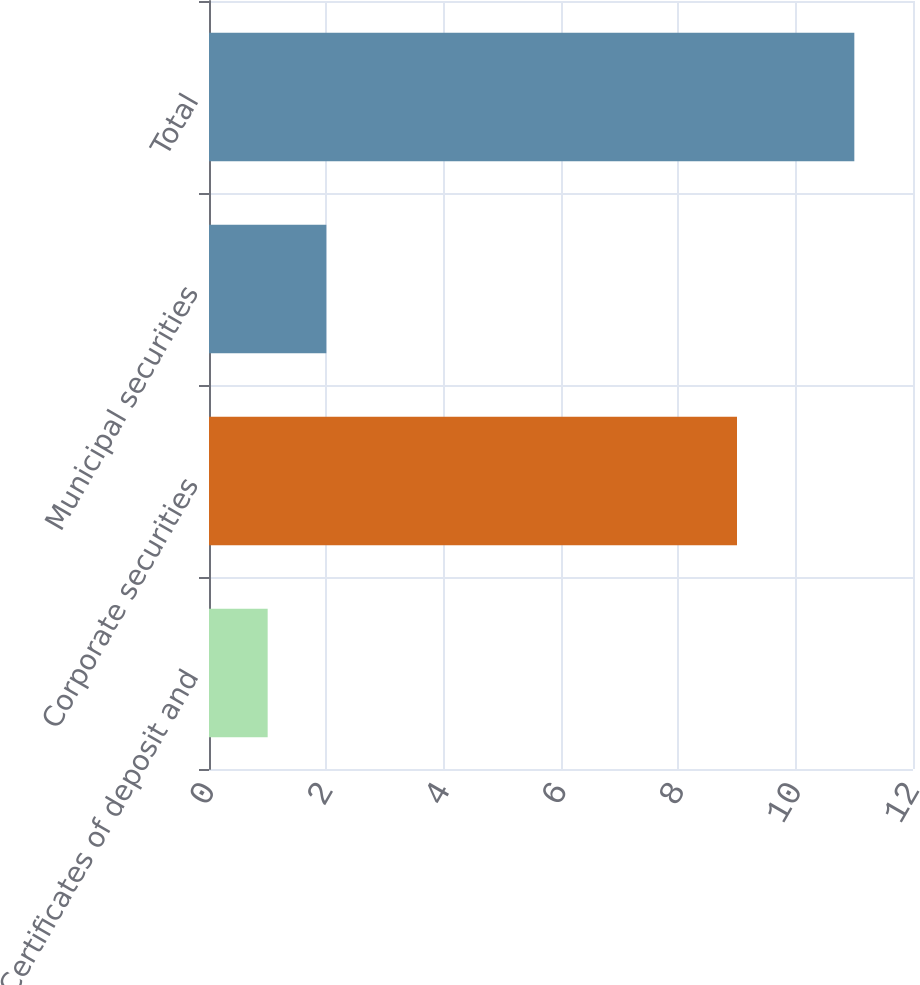Convert chart to OTSL. <chart><loc_0><loc_0><loc_500><loc_500><bar_chart><fcel>Certificates of deposit and<fcel>Corporate securities<fcel>Municipal securities<fcel>Total<nl><fcel>1<fcel>9<fcel>2<fcel>11<nl></chart> 